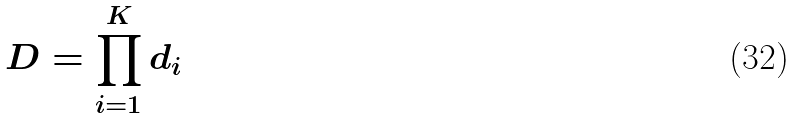<formula> <loc_0><loc_0><loc_500><loc_500>D = \prod _ { i = 1 } ^ { K } d _ { i }</formula> 